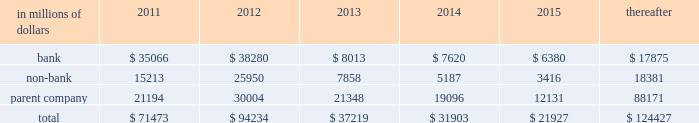Cgmhi has committed long-term financing facilities with unaffiliated banks .
At december 31 , 2010 , cgmhi had drawn down the full $ 900 million available under these facilities , of which $ 150 million is guaranteed by citigroup .
Generally , a bank can terminate these facilities by giving cgmhi one-year prior notice .
The company issues both fixed and variable rate debt in a range of currencies .
It uses derivative contracts , primarily interest rate swaps , to effectively convert a portion of its fixed rate debt to variable rate debt and variable rate debt to fixed rate debt .
The maturity structure of the derivatives generally corresponds to the maturity structure of the debt being hedged .
In addition , the company uses other derivative contracts to manage the foreign exchange impact of certain debt issuances .
At december 31 , 2010 , the company 2019s overall weighted average interest rate for long-term debt was 3.53% ( 3.53 % ) on a contractual basis and 2.78% ( 2.78 % ) including the effects of derivative contracts .
Aggregate annual maturities of long-term debt obligations ( based on final maturity dates ) including trust preferred securities are as follows : long-term debt at december 31 , 2010 and december 31 , 2009 includes $ 18131 million and $ 19345 million , respectively , of junior subordinated debt .
The company formed statutory business trusts under the laws of the state of delaware .
The trusts exist for the exclusive purposes of ( i ) issuing trust securities representing undivided beneficial interests in the assets of the trust ; ( ii ) investing the gross proceeds of the trust securities in junior subordinated deferrable interest debentures ( subordinated debentures ) of its parent ; and ( iii ) engaging in only those activities necessary or incidental thereto .
Upon approval from the federal reserve , citigroup has the right to redeem these securities .
Citigroup has contractually agreed not to redeem or purchase ( i ) the 6.50% ( 6.50 % ) enhanced trust preferred securities of citigroup capital xv before september 15 , 2056 , ( ii ) the 6.45% ( 6.45 % ) enhanced trust preferred securities of citigroup capital xvi before december 31 , 2046 , ( iii ) the 6.35% ( 6.35 % ) enhanced trust preferred securities of citigroup capital xvii before march 15 , 2057 , ( iv ) the 6.829% ( 6.829 % ) fixed rate/floating rate enhanced trust preferred securities of citigroup capital xviii before june 28 , 2047 , ( v ) the 7.250% ( 7.250 % ) enhanced trust preferred securities of citigroup capital xix before august 15 , 2047 , ( vi ) the 7.875% ( 7.875 % ) enhanced trust preferred securities of citigroup capital xx before december 15 , 2067 , and ( vii ) the 8.300% ( 8.300 % ) fixed rate/floating rate enhanced trust preferred securities of citigroup capital xxi before december 21 , 2067 , unless certain conditions , described in exhibit 4.03 to citigroup 2019s current report on form 8-k filed on september 18 , 2006 , in exhibit 4.02 to citigroup 2019s current report on form 8-k filed on november 28 , 2006 , in exhibit 4.02 to citigroup 2019s current report on form 8-k filed on march 8 , 2007 , in exhibit 4.02 to citigroup 2019s current report on form 8-k filed on july 2 , 2007 , in exhibit 4.02 to citigroup 2019s current report on form 8-k filed on august 17 , 2007 , in exhibit 4.2 to citigroup 2019s current report on form 8-k filed on november 27 , 2007 , and in exhibit 4.2 to citigroup 2019s current report on form 8-k filed on december 21 , 2007 , respectively , are met .
These agreements are for the benefit of the holders of citigroup 2019s 6.00% ( 6.00 % ) junior subordinated deferrable interest debentures due 2034 .
Citigroup owns all of the voting securities of these subsidiary trusts .
These subsidiary trusts have no assets , operations , revenues or cash flows other than those related to the issuance , administration , and repayment of the subsidiary trusts and the subsidiary trusts 2019 common securities .
These subsidiary trusts 2019 obligations are fully and unconditionally guaranteed by citigroup. .

In 2011 what percentage of total subsidiary trusts obligations are due to bank subsidiary? 
Computations: (35066 / 71473)
Answer: 0.49062. 